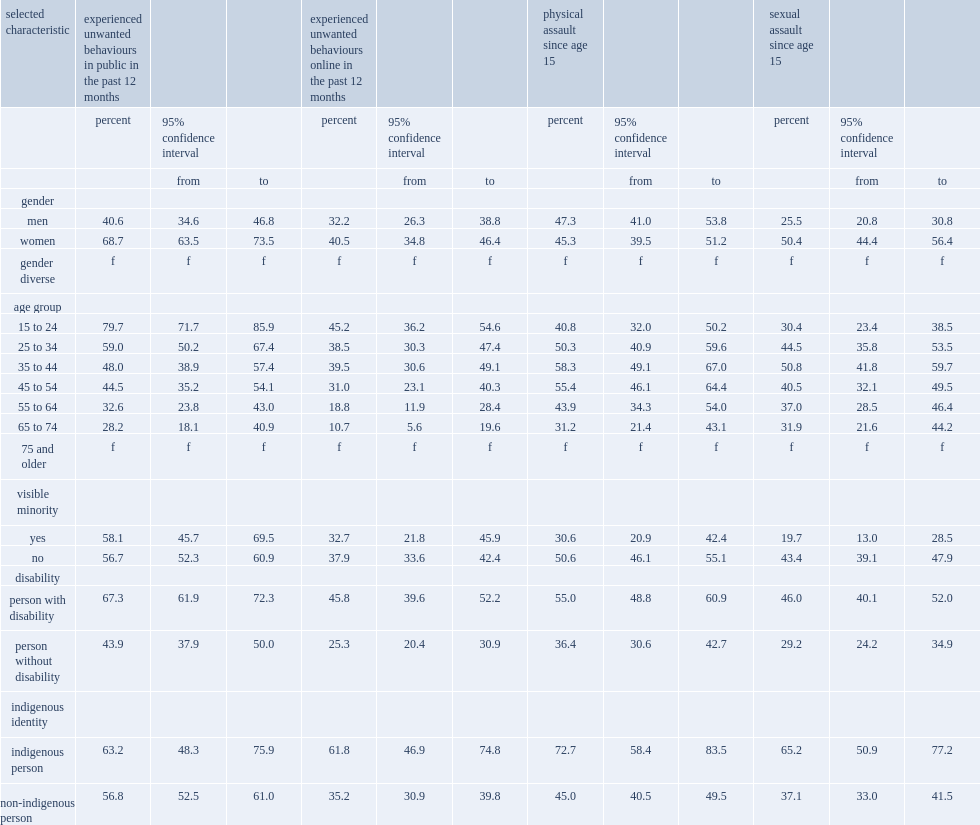Which group of people were more likely to report that they had been physically assaulted and sexually assaulted since age 15? sexual minority canadians with a disability or those who did not have a disability? Person with disability. Which group of people are more likely to have experienced both types of violent victimization since age 15? sexual minority people who self-identified as indigenous those of non-indigenous sexual minorities. Indigenous person. Which gourp of people were more likely to have experienced an inappropriate behaviour in public? sexual minority canadians with a disability or those who did not have a disability? Person with disability. Which group of people were more likely to have experienced an inappropriate behaviour while online? sexual minority canadians with a disability or those without a disability? Person with disability. Which group of people are more likely to have experienced inappropriate behaviours online? indigenous sexual minorities or non-indigenous sexual minorities? Indigenous person. 